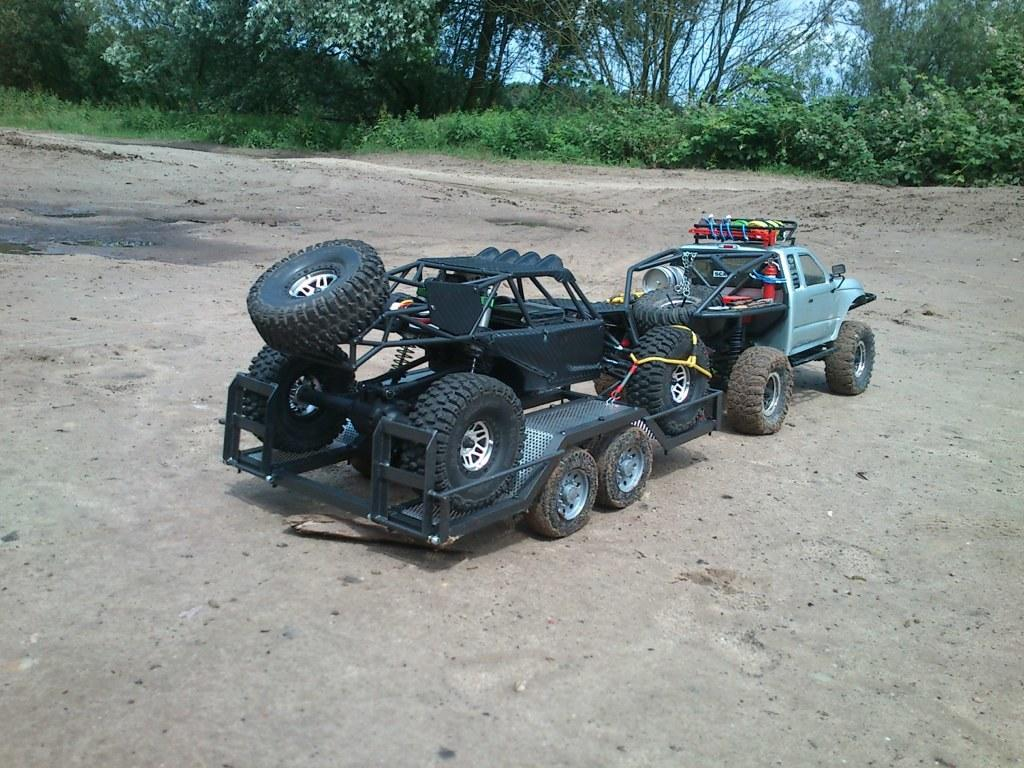What can be seen on the road in the image? There are vehicles on the road in the image. What is visible in the background of the image? There are trees and plants in the background of the image. What type of division is taking place in the image? There is no division taking place in the image; it features vehicles on the road and trees and plants in the background. What type of eggnog can be seen in the image? There is no eggnog present in the image. 